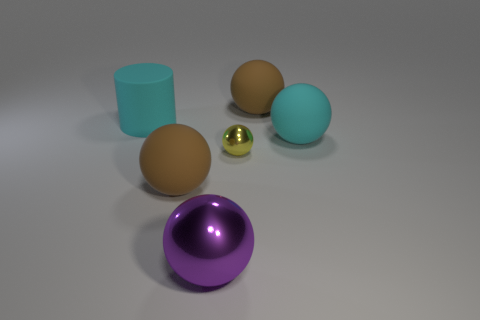How many rubber spheres are the same color as the large rubber cylinder?
Ensure brevity in your answer.  1. There is a cyan matte thing that is the same shape as the large metal object; what is its size?
Your response must be concise. Large. Is the number of small metallic balls behind the large matte cylinder greater than the number of yellow metallic objects in front of the purple ball?
Your response must be concise. No. Do the tiny thing and the brown ball that is in front of the large cylinder have the same material?
Offer a very short reply. No. Are there any other things that are the same shape as the tiny yellow metallic object?
Your answer should be very brief. Yes. There is a large rubber object that is both to the left of the cyan rubber sphere and on the right side of the big metallic object; what color is it?
Your answer should be very brief. Brown. What shape is the cyan matte object on the left side of the big cyan sphere?
Provide a succinct answer. Cylinder. What is the size of the matte thing that is in front of the tiny metallic object that is to the right of the brown rubber object that is in front of the cylinder?
Give a very brief answer. Large. There is a brown rubber thing that is to the right of the big purple object; how many big balls are in front of it?
Your answer should be compact. 3. There is a matte sphere that is in front of the cylinder and right of the big purple shiny sphere; what is its size?
Give a very brief answer. Large. 